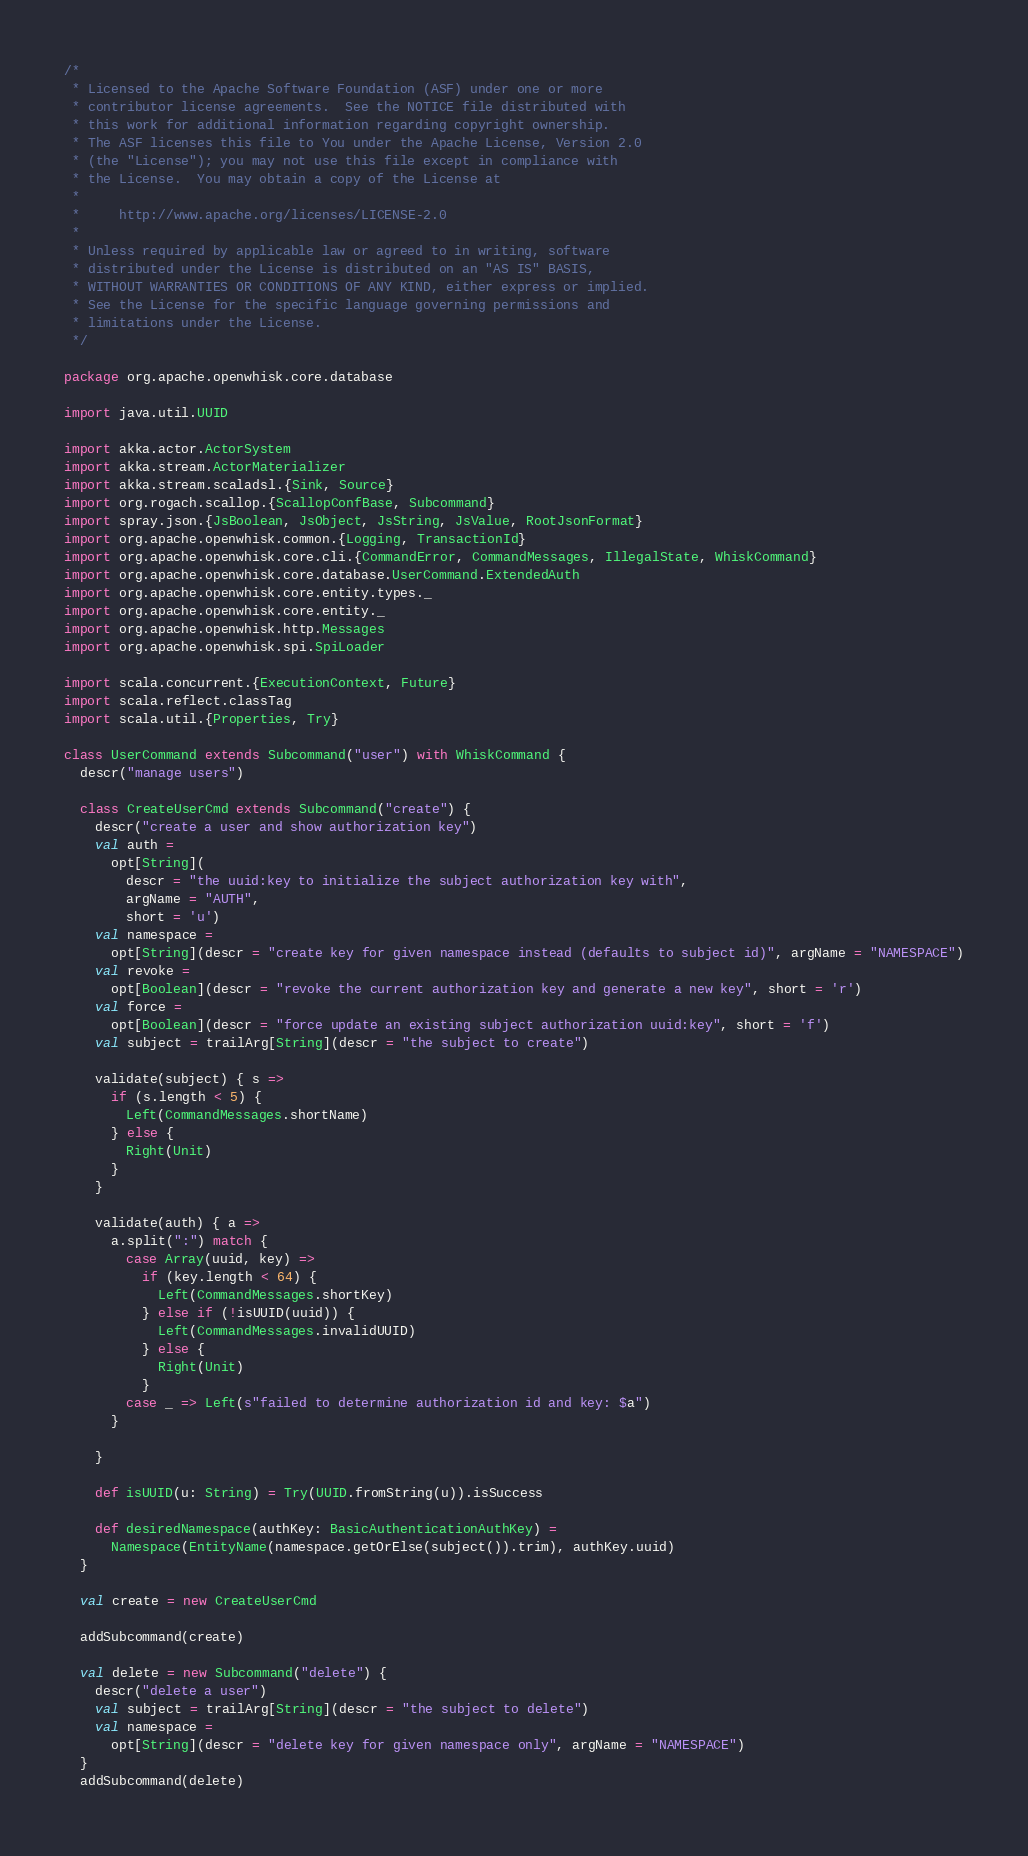<code> <loc_0><loc_0><loc_500><loc_500><_Scala_>/*
 * Licensed to the Apache Software Foundation (ASF) under one or more
 * contributor license agreements.  See the NOTICE file distributed with
 * this work for additional information regarding copyright ownership.
 * The ASF licenses this file to You under the Apache License, Version 2.0
 * (the "License"); you may not use this file except in compliance with
 * the License.  You may obtain a copy of the License at
 *
 *     http://www.apache.org/licenses/LICENSE-2.0
 *
 * Unless required by applicable law or agreed to in writing, software
 * distributed under the License is distributed on an "AS IS" BASIS,
 * WITHOUT WARRANTIES OR CONDITIONS OF ANY KIND, either express or implied.
 * See the License for the specific language governing permissions and
 * limitations under the License.
 */

package org.apache.openwhisk.core.database

import java.util.UUID

import akka.actor.ActorSystem
import akka.stream.ActorMaterializer
import akka.stream.scaladsl.{Sink, Source}
import org.rogach.scallop.{ScallopConfBase, Subcommand}
import spray.json.{JsBoolean, JsObject, JsString, JsValue, RootJsonFormat}
import org.apache.openwhisk.common.{Logging, TransactionId}
import org.apache.openwhisk.core.cli.{CommandError, CommandMessages, IllegalState, WhiskCommand}
import org.apache.openwhisk.core.database.UserCommand.ExtendedAuth
import org.apache.openwhisk.core.entity.types._
import org.apache.openwhisk.core.entity._
import org.apache.openwhisk.http.Messages
import org.apache.openwhisk.spi.SpiLoader

import scala.concurrent.{ExecutionContext, Future}
import scala.reflect.classTag
import scala.util.{Properties, Try}

class UserCommand extends Subcommand("user") with WhiskCommand {
  descr("manage users")

  class CreateUserCmd extends Subcommand("create") {
    descr("create a user and show authorization key")
    val auth =
      opt[String](
        descr = "the uuid:key to initialize the subject authorization key with",
        argName = "AUTH",
        short = 'u')
    val namespace =
      opt[String](descr = "create key for given namespace instead (defaults to subject id)", argName = "NAMESPACE")
    val revoke =
      opt[Boolean](descr = "revoke the current authorization key and generate a new key", short = 'r')
    val force =
      opt[Boolean](descr = "force update an existing subject authorization uuid:key", short = 'f')
    val subject = trailArg[String](descr = "the subject to create")

    validate(subject) { s =>
      if (s.length < 5) {
        Left(CommandMessages.shortName)
      } else {
        Right(Unit)
      }
    }

    validate(auth) { a =>
      a.split(":") match {
        case Array(uuid, key) =>
          if (key.length < 64) {
            Left(CommandMessages.shortKey)
          } else if (!isUUID(uuid)) {
            Left(CommandMessages.invalidUUID)
          } else {
            Right(Unit)
          }
        case _ => Left(s"failed to determine authorization id and key: $a")
      }

    }

    def isUUID(u: String) = Try(UUID.fromString(u)).isSuccess

    def desiredNamespace(authKey: BasicAuthenticationAuthKey) =
      Namespace(EntityName(namespace.getOrElse(subject()).trim), authKey.uuid)
  }

  val create = new CreateUserCmd

  addSubcommand(create)

  val delete = new Subcommand("delete") {
    descr("delete a user")
    val subject = trailArg[String](descr = "the subject to delete")
    val namespace =
      opt[String](descr = "delete key for given namespace only", argName = "NAMESPACE")
  }
  addSubcommand(delete)
</code> 